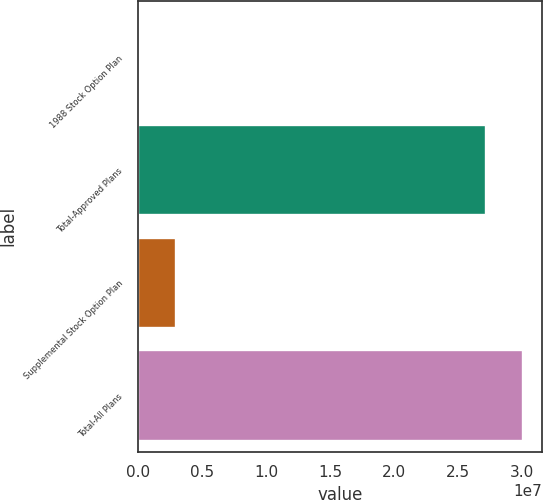<chart> <loc_0><loc_0><loc_500><loc_500><bar_chart><fcel>1988 Stock Option Plan<fcel>Total-Approved Plans<fcel>Supplemental Stock Option Plan<fcel>Total-All Plans<nl><fcel>2.39<fcel>2.71521e+07<fcel>2.93471e+06<fcel>3.00868e+07<nl></chart> 